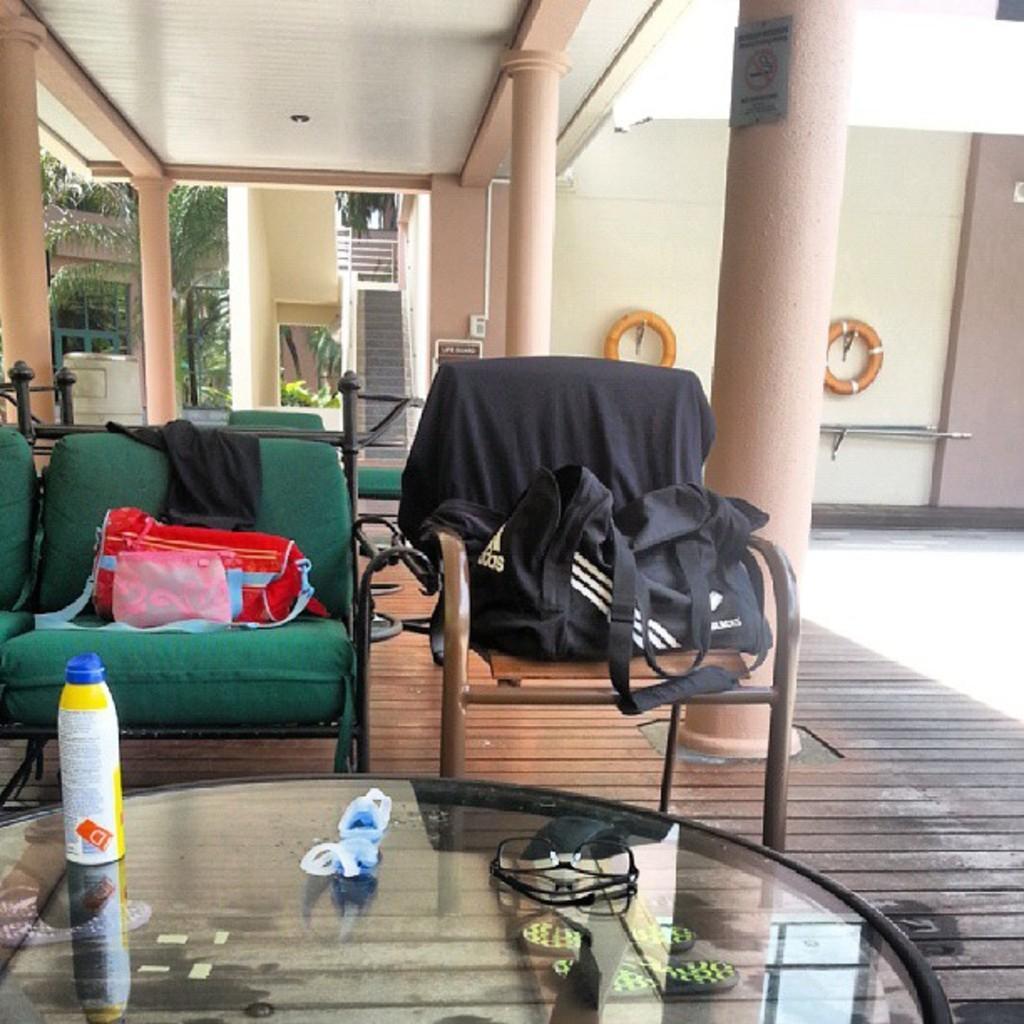Please provide a concise description of this image. In this picture there are two sofas in the middle. To the left corner there is a table. In the background there are 4 pillars, one staircase and a tree. To the right there are two tubes. 